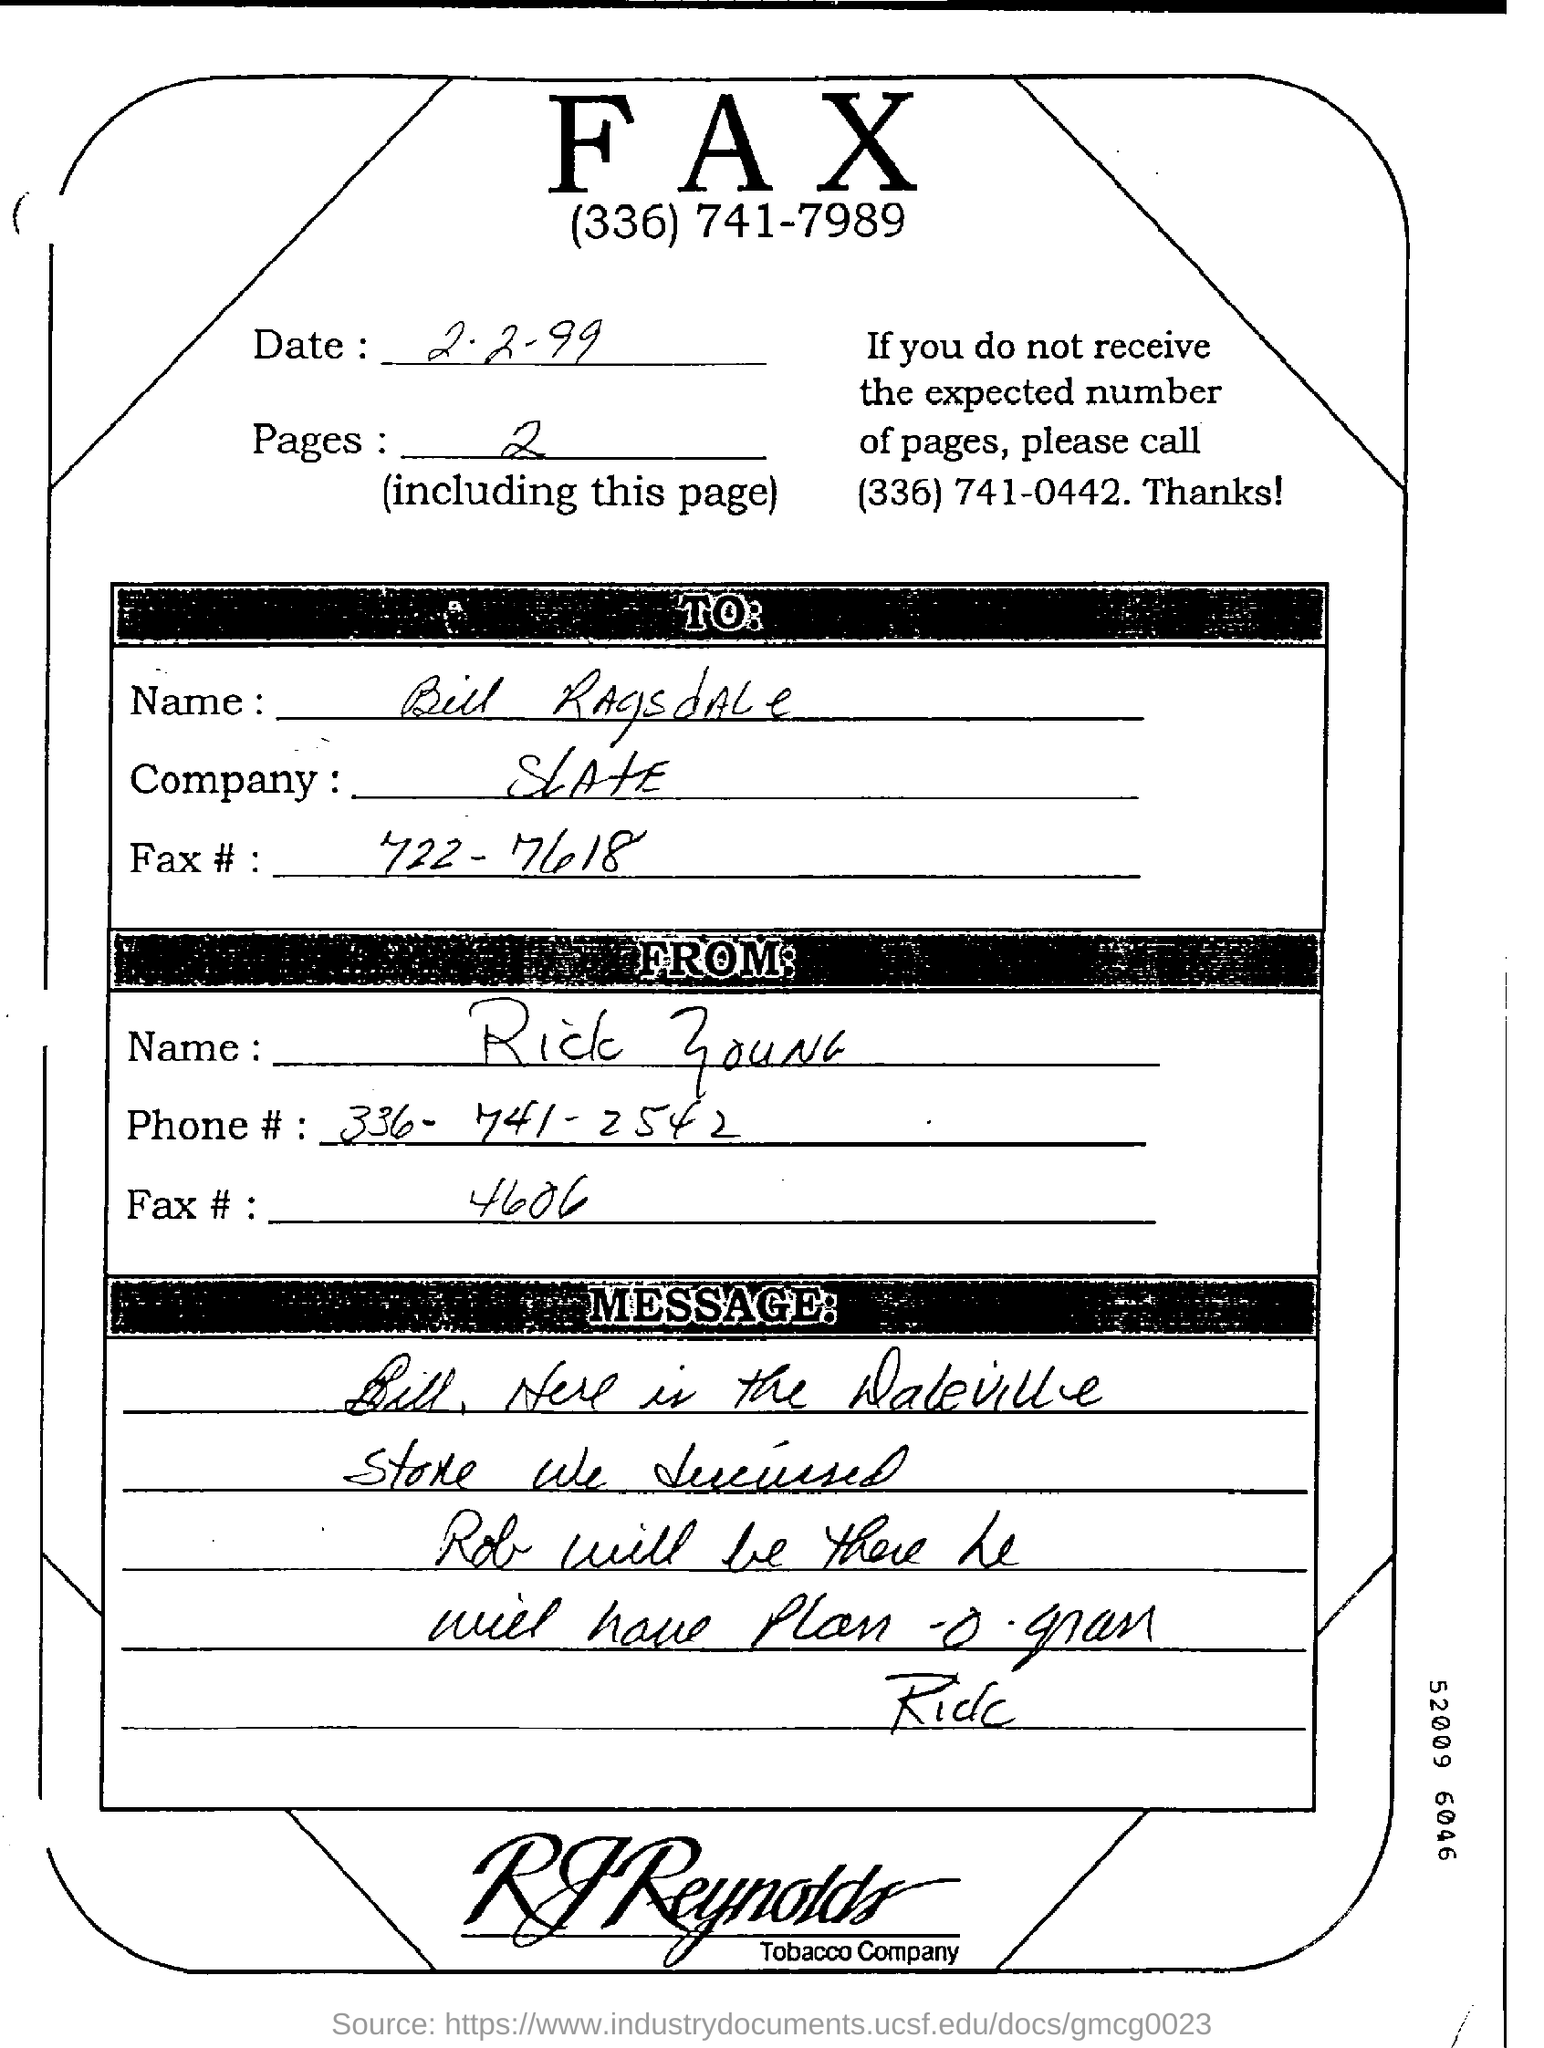Specify some key components in this picture. The number of pages is 2.. The fax number of Rick is 4606... The person to send a fax is named Bill Ragsdale. As of this page, there are a total of 2 pages. The date of the fax is 2.2.99... 